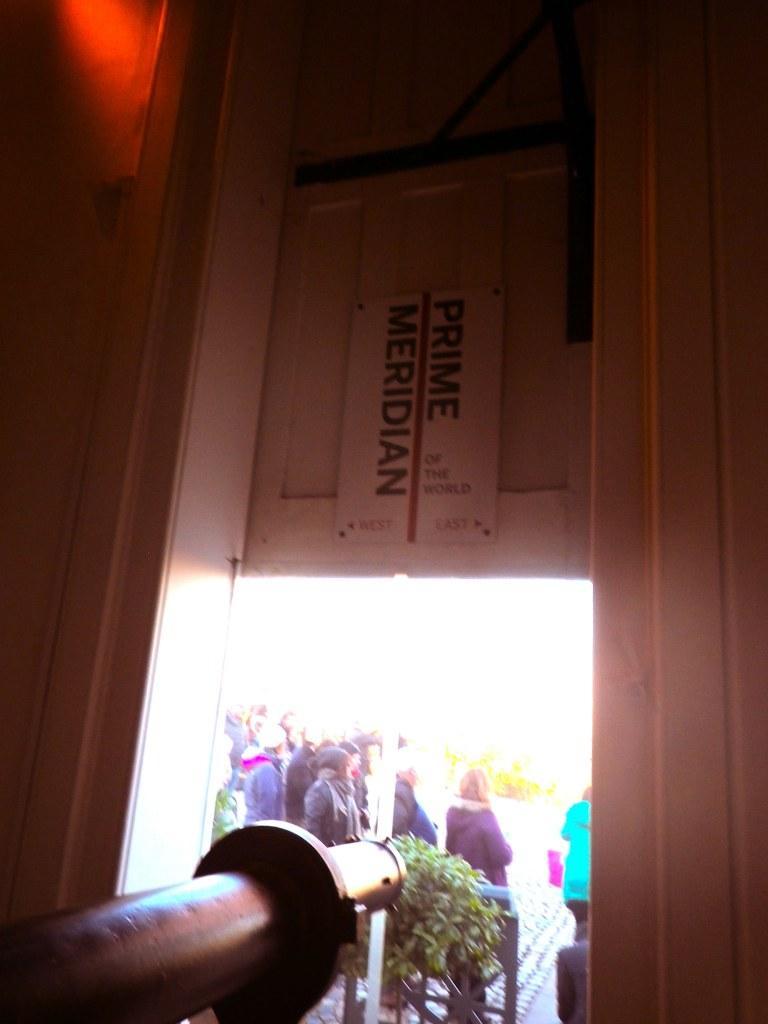Describe this image in one or two sentences. In the image I can see a place where we have a door, plant and some people to the side. 